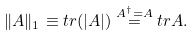<formula> <loc_0><loc_0><loc_500><loc_500>\| A \| _ { 1 } \equiv t r ( | A | ) \overset { A ^ { \dag } = A } { = } t r A .</formula> 